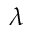Convert formula to latex. <formula><loc_0><loc_0><loc_500><loc_500>\lambda</formula> 